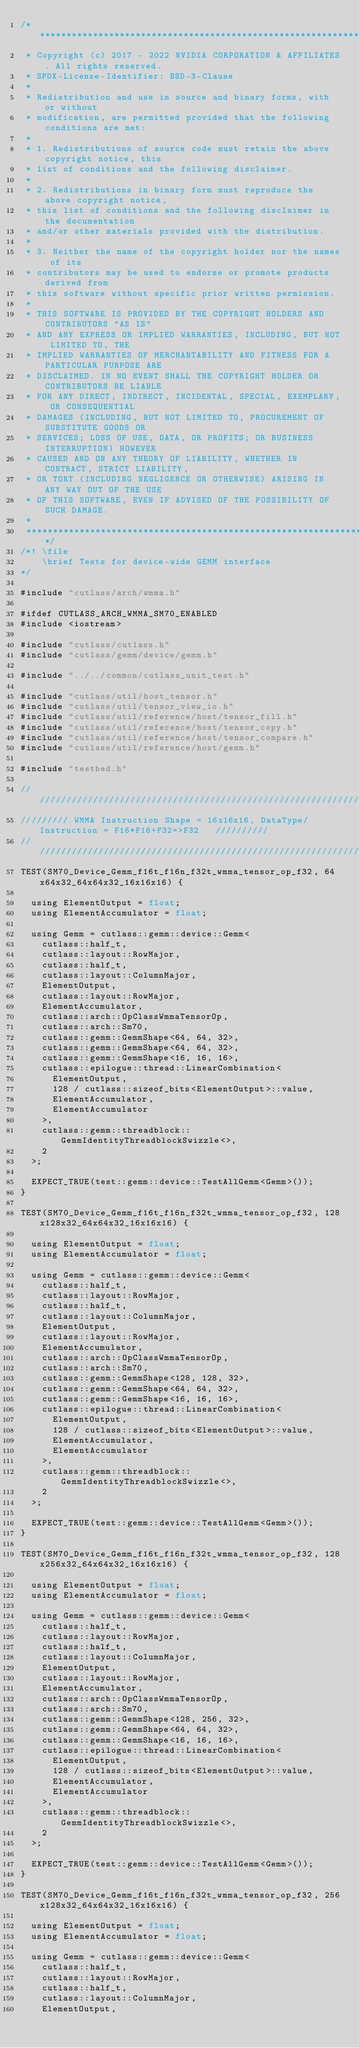Convert code to text. <code><loc_0><loc_0><loc_500><loc_500><_Cuda_>/***************************************************************************************************
 * Copyright (c) 2017 - 2022 NVIDIA CORPORATION & AFFILIATES. All rights reserved.
 * SPDX-License-Identifier: BSD-3-Clause
 *
 * Redistribution and use in source and binary forms, with or without
 * modification, are permitted provided that the following conditions are met:
 *
 * 1. Redistributions of source code must retain the above copyright notice, this
 * list of conditions and the following disclaimer.
 *
 * 2. Redistributions in binary form must reproduce the above copyright notice,
 * this list of conditions and the following disclaimer in the documentation
 * and/or other materials provided with the distribution.
 *
 * 3. Neither the name of the copyright holder nor the names of its
 * contributors may be used to endorse or promote products derived from
 * this software without specific prior written permission.
 *
 * THIS SOFTWARE IS PROVIDED BY THE COPYRIGHT HOLDERS AND CONTRIBUTORS "AS IS"
 * AND ANY EXPRESS OR IMPLIED WARRANTIES, INCLUDING, BUT NOT LIMITED TO, THE
 * IMPLIED WARRANTIES OF MERCHANTABILITY AND FITNESS FOR A PARTICULAR PURPOSE ARE
 * DISCLAIMED. IN NO EVENT SHALL THE COPYRIGHT HOLDER OR CONTRIBUTORS BE LIABLE
 * FOR ANY DIRECT, INDIRECT, INCIDENTAL, SPECIAL, EXEMPLARY, OR CONSEQUENTIAL
 * DAMAGES (INCLUDING, BUT NOT LIMITED TO, PROCUREMENT OF SUBSTITUTE GOODS OR
 * SERVICES; LOSS OF USE, DATA, OR PROFITS; OR BUSINESS INTERRUPTION) HOWEVER
 * CAUSED AND ON ANY THEORY OF LIABILITY, WHETHER IN CONTRACT, STRICT LIABILITY,
 * OR TORT (INCLUDING NEGLIGENCE OR OTHERWISE) ARISING IN ANY WAY OUT OF THE USE
 * OF THIS SOFTWARE, EVEN IF ADVISED OF THE POSSIBILITY OF SUCH DAMAGE.
 *
 **************************************************************************************************/
/*! \file
    \brief Tests for device-wide GEMM interface
*/

#include "cutlass/arch/wmma.h"

#ifdef CUTLASS_ARCH_WMMA_SM70_ENABLED
#include <iostream>

#include "cutlass/cutlass.h"
#include "cutlass/gemm/device/gemm.h"

#include "../../common/cutlass_unit_test.h"

#include "cutlass/util/host_tensor.h"
#include "cutlass/util/tensor_view_io.h"
#include "cutlass/util/reference/host/tensor_fill.h"
#include "cutlass/util/reference/host/tensor_copy.h"
#include "cutlass/util/reference/host/tensor_compare.h"
#include "cutlass/util/reference/host/gemm.h"

#include "testbed.h"

/////////////////////////////////////////////////////////////////////////////////////////////////
///////// WMMA Instruction Shape = 16x16x16, DataType/Instruction = F16*F16+F32=>F32   //////////
/////////////////////////////////////////////////////////////////////////////////////////////////  
TEST(SM70_Device_Gemm_f16t_f16n_f32t_wmma_tensor_op_f32, 64x64x32_64x64x32_16x16x16) {

  using ElementOutput = float;
  using ElementAccumulator = float;

  using Gemm = cutlass::gemm::device::Gemm<
    cutlass::half_t,
    cutlass::layout::RowMajor,
    cutlass::half_t,
    cutlass::layout::ColumnMajor,
    ElementOutput,
    cutlass::layout::RowMajor,
    ElementAccumulator,
    cutlass::arch::OpClassWmmaTensorOp,
    cutlass::arch::Sm70,
    cutlass::gemm::GemmShape<64, 64, 32>,
    cutlass::gemm::GemmShape<64, 64, 32>,
    cutlass::gemm::GemmShape<16, 16, 16>,
    cutlass::epilogue::thread::LinearCombination<
      ElementOutput,
      128 / cutlass::sizeof_bits<ElementOutput>::value,
      ElementAccumulator,
      ElementAccumulator
    >,
    cutlass::gemm::threadblock::GemmIdentityThreadblockSwizzle<>,
    2
  >;

  EXPECT_TRUE(test::gemm::device::TestAllGemm<Gemm>());
}

TEST(SM70_Device_Gemm_f16t_f16n_f32t_wmma_tensor_op_f32, 128x128x32_64x64x32_16x16x16) {

  using ElementOutput = float;
  using ElementAccumulator = float;

  using Gemm = cutlass::gemm::device::Gemm<
    cutlass::half_t,
    cutlass::layout::RowMajor,
    cutlass::half_t,
    cutlass::layout::ColumnMajor,
    ElementOutput,
    cutlass::layout::RowMajor,
    ElementAccumulator,
    cutlass::arch::OpClassWmmaTensorOp,
    cutlass::arch::Sm70,
    cutlass::gemm::GemmShape<128, 128, 32>,
    cutlass::gemm::GemmShape<64, 64, 32>,
    cutlass::gemm::GemmShape<16, 16, 16>,
    cutlass::epilogue::thread::LinearCombination<
      ElementOutput,
      128 / cutlass::sizeof_bits<ElementOutput>::value,
      ElementAccumulator,
      ElementAccumulator
    >,
    cutlass::gemm::threadblock::GemmIdentityThreadblockSwizzle<>,
    2
  >;

  EXPECT_TRUE(test::gemm::device::TestAllGemm<Gemm>());
}

TEST(SM70_Device_Gemm_f16t_f16n_f32t_wmma_tensor_op_f32, 128x256x32_64x64x32_16x16x16) {

  using ElementOutput = float;
  using ElementAccumulator = float;

  using Gemm = cutlass::gemm::device::Gemm<
    cutlass::half_t,
    cutlass::layout::RowMajor,
    cutlass::half_t,
    cutlass::layout::ColumnMajor,
    ElementOutput,
    cutlass::layout::RowMajor,
    ElementAccumulator,
    cutlass::arch::OpClassWmmaTensorOp,
    cutlass::arch::Sm70,
    cutlass::gemm::GemmShape<128, 256, 32>,
    cutlass::gemm::GemmShape<64, 64, 32>,
    cutlass::gemm::GemmShape<16, 16, 16>,
    cutlass::epilogue::thread::LinearCombination<
      ElementOutput,
      128 / cutlass::sizeof_bits<ElementOutput>::value,
      ElementAccumulator,
      ElementAccumulator
    >,
    cutlass::gemm::threadblock::GemmIdentityThreadblockSwizzle<>,
    2
  >;

  EXPECT_TRUE(test::gemm::device::TestAllGemm<Gemm>());
}

TEST(SM70_Device_Gemm_f16t_f16n_f32t_wmma_tensor_op_f32, 256x128x32_64x64x32_16x16x16) {

  using ElementOutput = float;
  using ElementAccumulator = float;

  using Gemm = cutlass::gemm::device::Gemm<
    cutlass::half_t,
    cutlass::layout::RowMajor,
    cutlass::half_t,
    cutlass::layout::ColumnMajor,
    ElementOutput,</code> 